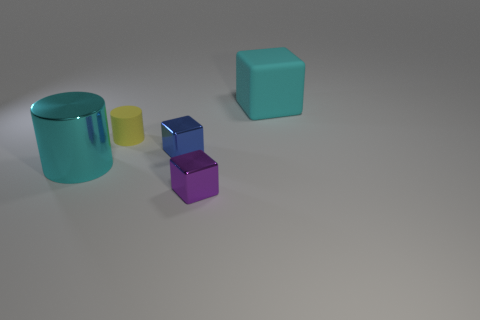Is the number of yellow things left of the blue shiny thing less than the number of big yellow metal objects?
Make the answer very short. No. How many metallic cylinders have the same color as the large rubber block?
Offer a very short reply. 1. There is a cube that is both behind the purple cube and in front of the big cyan matte cube; what is it made of?
Provide a short and direct response. Metal. There is a big thing behind the yellow object; is it the same color as the big object to the left of the cyan rubber block?
Your response must be concise. Yes. How many cyan objects are rubber blocks or small matte cubes?
Offer a very short reply. 1. Are there fewer tiny blue cubes behind the big cyan metallic cylinder than small objects that are in front of the matte cylinder?
Offer a very short reply. Yes. Are there any blue things of the same size as the matte cylinder?
Your answer should be very brief. Yes. Do the metallic object to the left of the blue object and the tiny purple cube have the same size?
Your answer should be compact. No. Is the number of yellow matte cylinders greater than the number of large purple metallic cylinders?
Offer a terse response. Yes. Are there any other yellow things that have the same shape as the large metallic thing?
Give a very brief answer. Yes. 